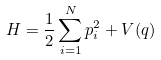Convert formula to latex. <formula><loc_0><loc_0><loc_500><loc_500>H = \frac { 1 } { 2 } \sum _ { i = 1 } ^ { N } p _ { i } ^ { 2 } + V ( q )</formula> 